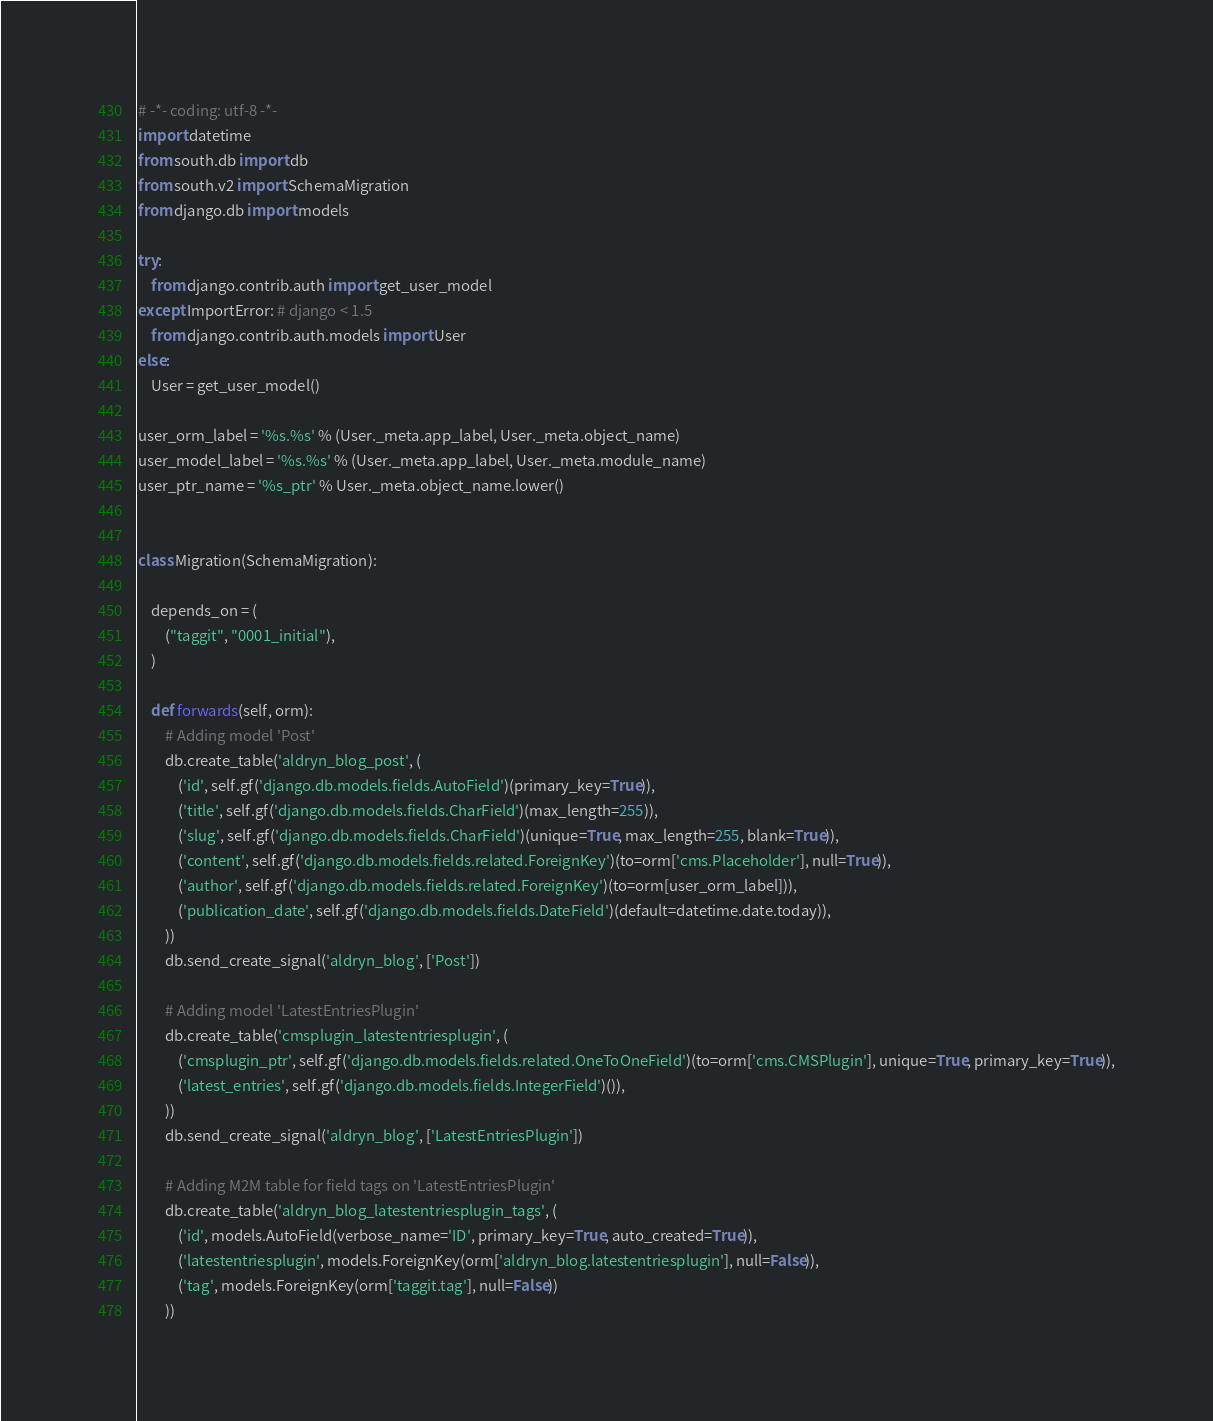<code> <loc_0><loc_0><loc_500><loc_500><_Python_># -*- coding: utf-8 -*-
import datetime
from south.db import db
from south.v2 import SchemaMigration
from django.db import models

try:
    from django.contrib.auth import get_user_model
except ImportError: # django < 1.5
    from django.contrib.auth.models import User
else:
    User = get_user_model()

user_orm_label = '%s.%s' % (User._meta.app_label, User._meta.object_name)
user_model_label = '%s.%s' % (User._meta.app_label, User._meta.module_name)
user_ptr_name = '%s_ptr' % User._meta.object_name.lower()


class Migration(SchemaMigration):

    depends_on = (
        ("taggit", "0001_initial"),
    )

    def forwards(self, orm):
        # Adding model 'Post'
        db.create_table('aldryn_blog_post', (
            ('id', self.gf('django.db.models.fields.AutoField')(primary_key=True)),
            ('title', self.gf('django.db.models.fields.CharField')(max_length=255)),
            ('slug', self.gf('django.db.models.fields.CharField')(unique=True, max_length=255, blank=True)),
            ('content', self.gf('django.db.models.fields.related.ForeignKey')(to=orm['cms.Placeholder'], null=True)),
            ('author', self.gf('django.db.models.fields.related.ForeignKey')(to=orm[user_orm_label])),
            ('publication_date', self.gf('django.db.models.fields.DateField')(default=datetime.date.today)),
        ))
        db.send_create_signal('aldryn_blog', ['Post'])

        # Adding model 'LatestEntriesPlugin'
        db.create_table('cmsplugin_latestentriesplugin', (
            ('cmsplugin_ptr', self.gf('django.db.models.fields.related.OneToOneField')(to=orm['cms.CMSPlugin'], unique=True, primary_key=True)),
            ('latest_entries', self.gf('django.db.models.fields.IntegerField')()),
        ))
        db.send_create_signal('aldryn_blog', ['LatestEntriesPlugin'])

        # Adding M2M table for field tags on 'LatestEntriesPlugin'
        db.create_table('aldryn_blog_latestentriesplugin_tags', (
            ('id', models.AutoField(verbose_name='ID', primary_key=True, auto_created=True)),
            ('latestentriesplugin', models.ForeignKey(orm['aldryn_blog.latestentriesplugin'], null=False)),
            ('tag', models.ForeignKey(orm['taggit.tag'], null=False))
        ))</code> 